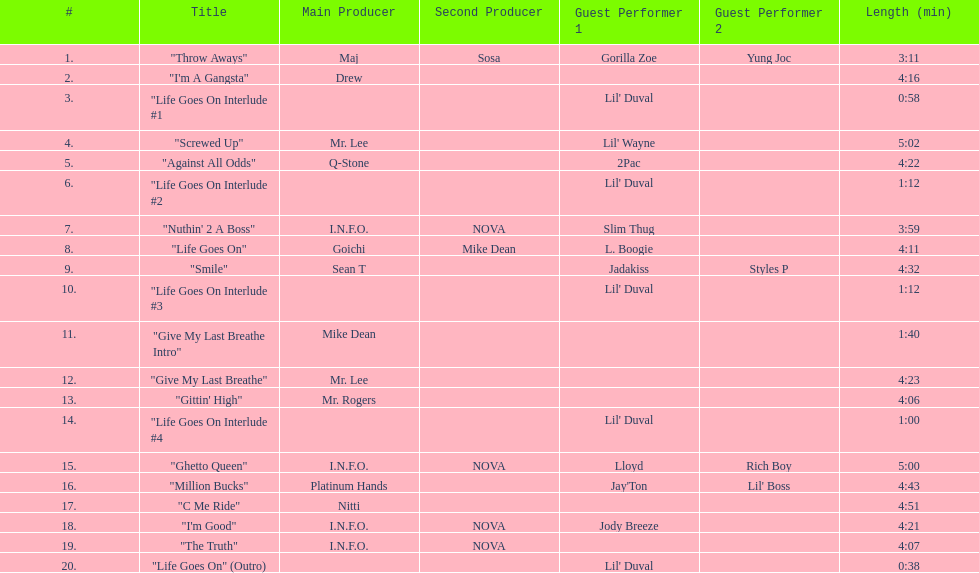How long is track number 11? 1:40. 